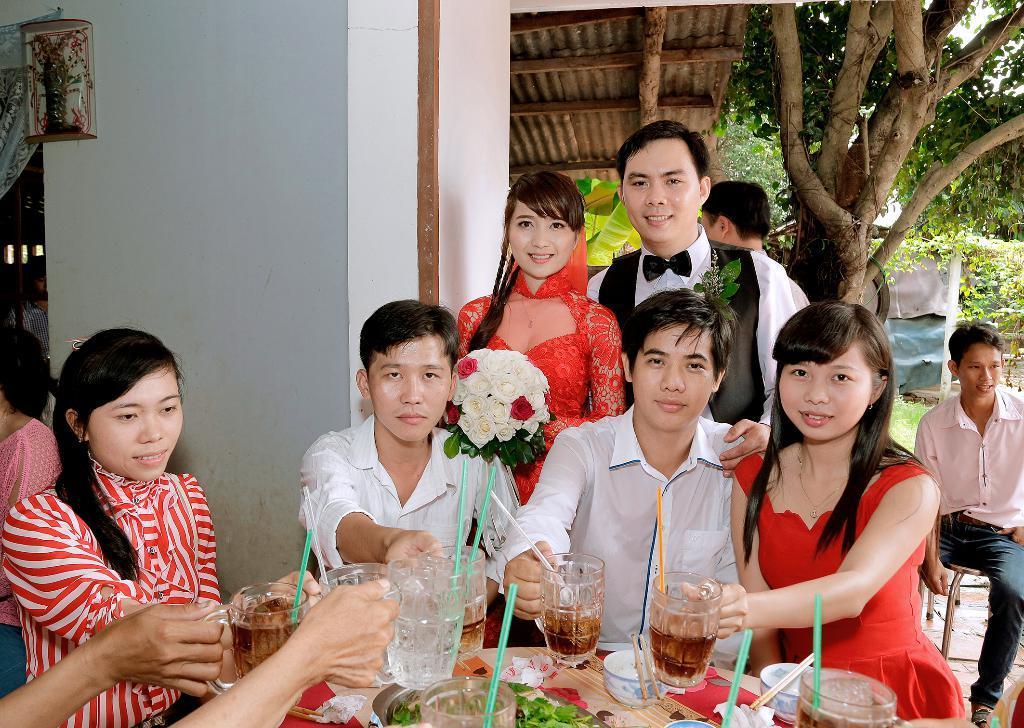Please provide a concise description of this image. In this image I can see there are few persons visible in front of the table and some persons holding glasses , glasses contain drink and straws and on table table I can see glass, leaves and bowls and I can see two persons and they both are smiling and a woman wearing a red color dress , holding a flower boo key and I can see a person and the wall and curtain visible on left side and I can see a person sitting on chair and his smiling and trees and crepes visible on the right side. 